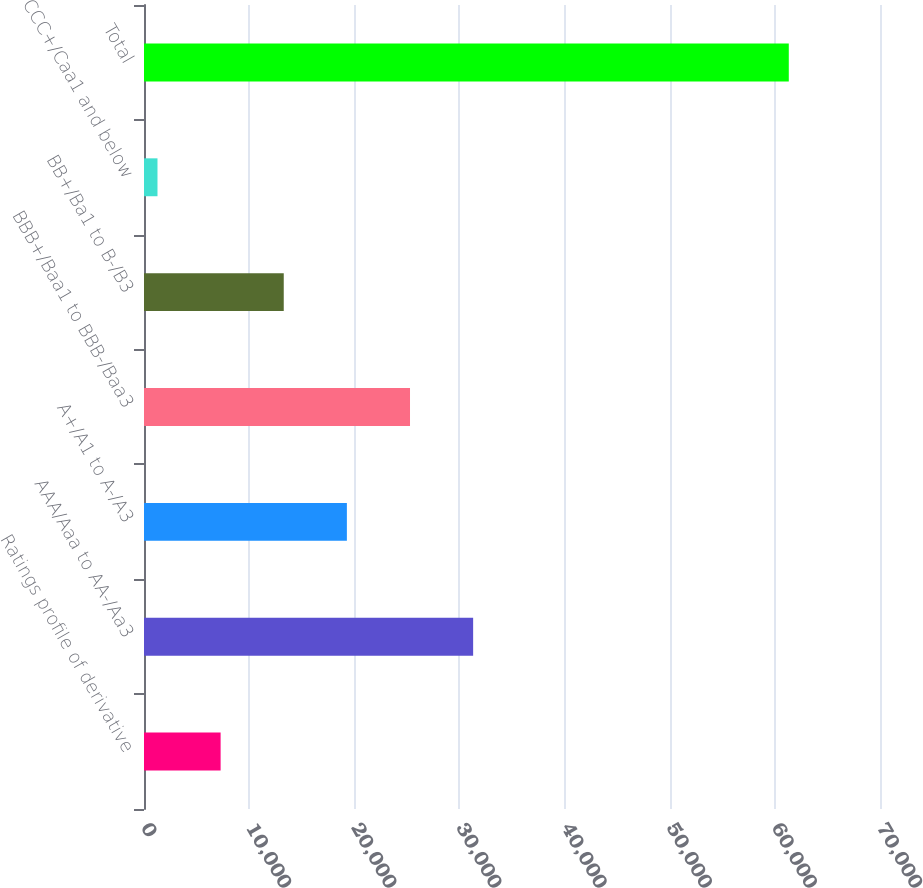<chart> <loc_0><loc_0><loc_500><loc_500><bar_chart><fcel>Ratings profile of derivative<fcel>AAA/Aaa to AA-/Aa3<fcel>A+/A1 to A-/A3<fcel>BBB+/Baa1 to BBB-/Baa3<fcel>BB+/Ba1 to B-/B3<fcel>CCC+/Caa1 and below<fcel>Total<nl><fcel>7287.2<fcel>31304<fcel>19295.6<fcel>25299.8<fcel>13291.4<fcel>1283<fcel>61325<nl></chart> 